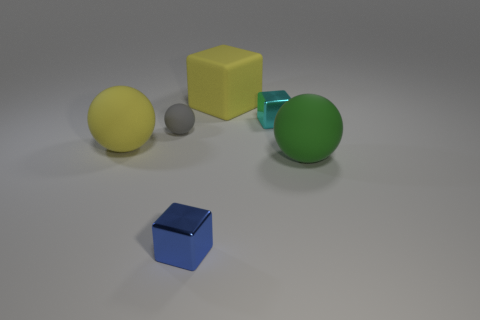Do the cyan metallic thing behind the small gray thing and the big green object have the same shape?
Your answer should be very brief. No. Does the big sphere in front of the large yellow rubber ball have the same material as the cyan cube?
Your answer should be very brief. No. There is a small cube that is left of the big object behind the large sphere behind the large green thing; what is it made of?
Your answer should be compact. Metal. What number of other objects are there of the same shape as the gray rubber thing?
Provide a succinct answer. 2. What is the color of the matte thing behind the cyan cube?
Your answer should be very brief. Yellow. How many balls are to the right of the metal cube on the right side of the thing in front of the green rubber ball?
Offer a terse response. 1. How many metallic objects are behind the big matte ball to the left of the yellow rubber block?
Offer a terse response. 1. There is a small gray rubber thing; how many cyan objects are behind it?
Offer a terse response. 1. How many other objects are there of the same size as the cyan cube?
Keep it short and to the point. 2. There is a yellow object that is the same shape as the large green object; what size is it?
Your answer should be compact. Large. 